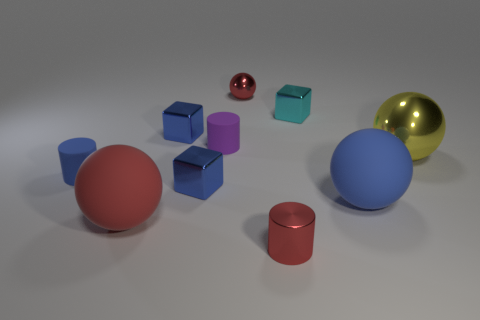Subtract all cyan metallic blocks. How many blocks are left? 2 Subtract all yellow balls. How many balls are left? 3 Subtract 3 cylinders. How many cylinders are left? 0 Add 7 blue matte balls. How many blue matte balls are left? 8 Add 5 large spheres. How many large spheres exist? 8 Subtract 0 brown cylinders. How many objects are left? 10 Subtract all cylinders. How many objects are left? 7 Subtract all green spheres. Subtract all brown cylinders. How many spheres are left? 4 Subtract all cyan blocks. How many purple balls are left? 0 Subtract all big yellow matte things. Subtract all purple objects. How many objects are left? 9 